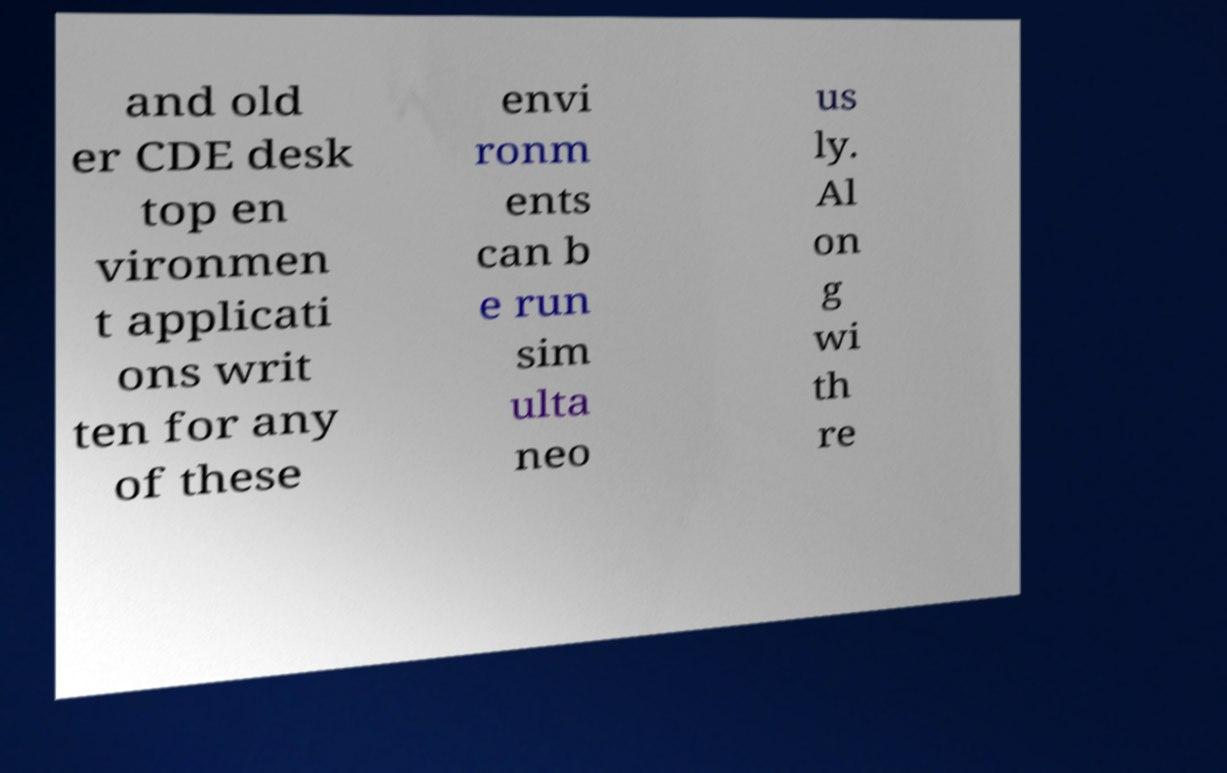I need the written content from this picture converted into text. Can you do that? and old er CDE desk top en vironmen t applicati ons writ ten for any of these envi ronm ents can b e run sim ulta neo us ly. Al on g wi th re 